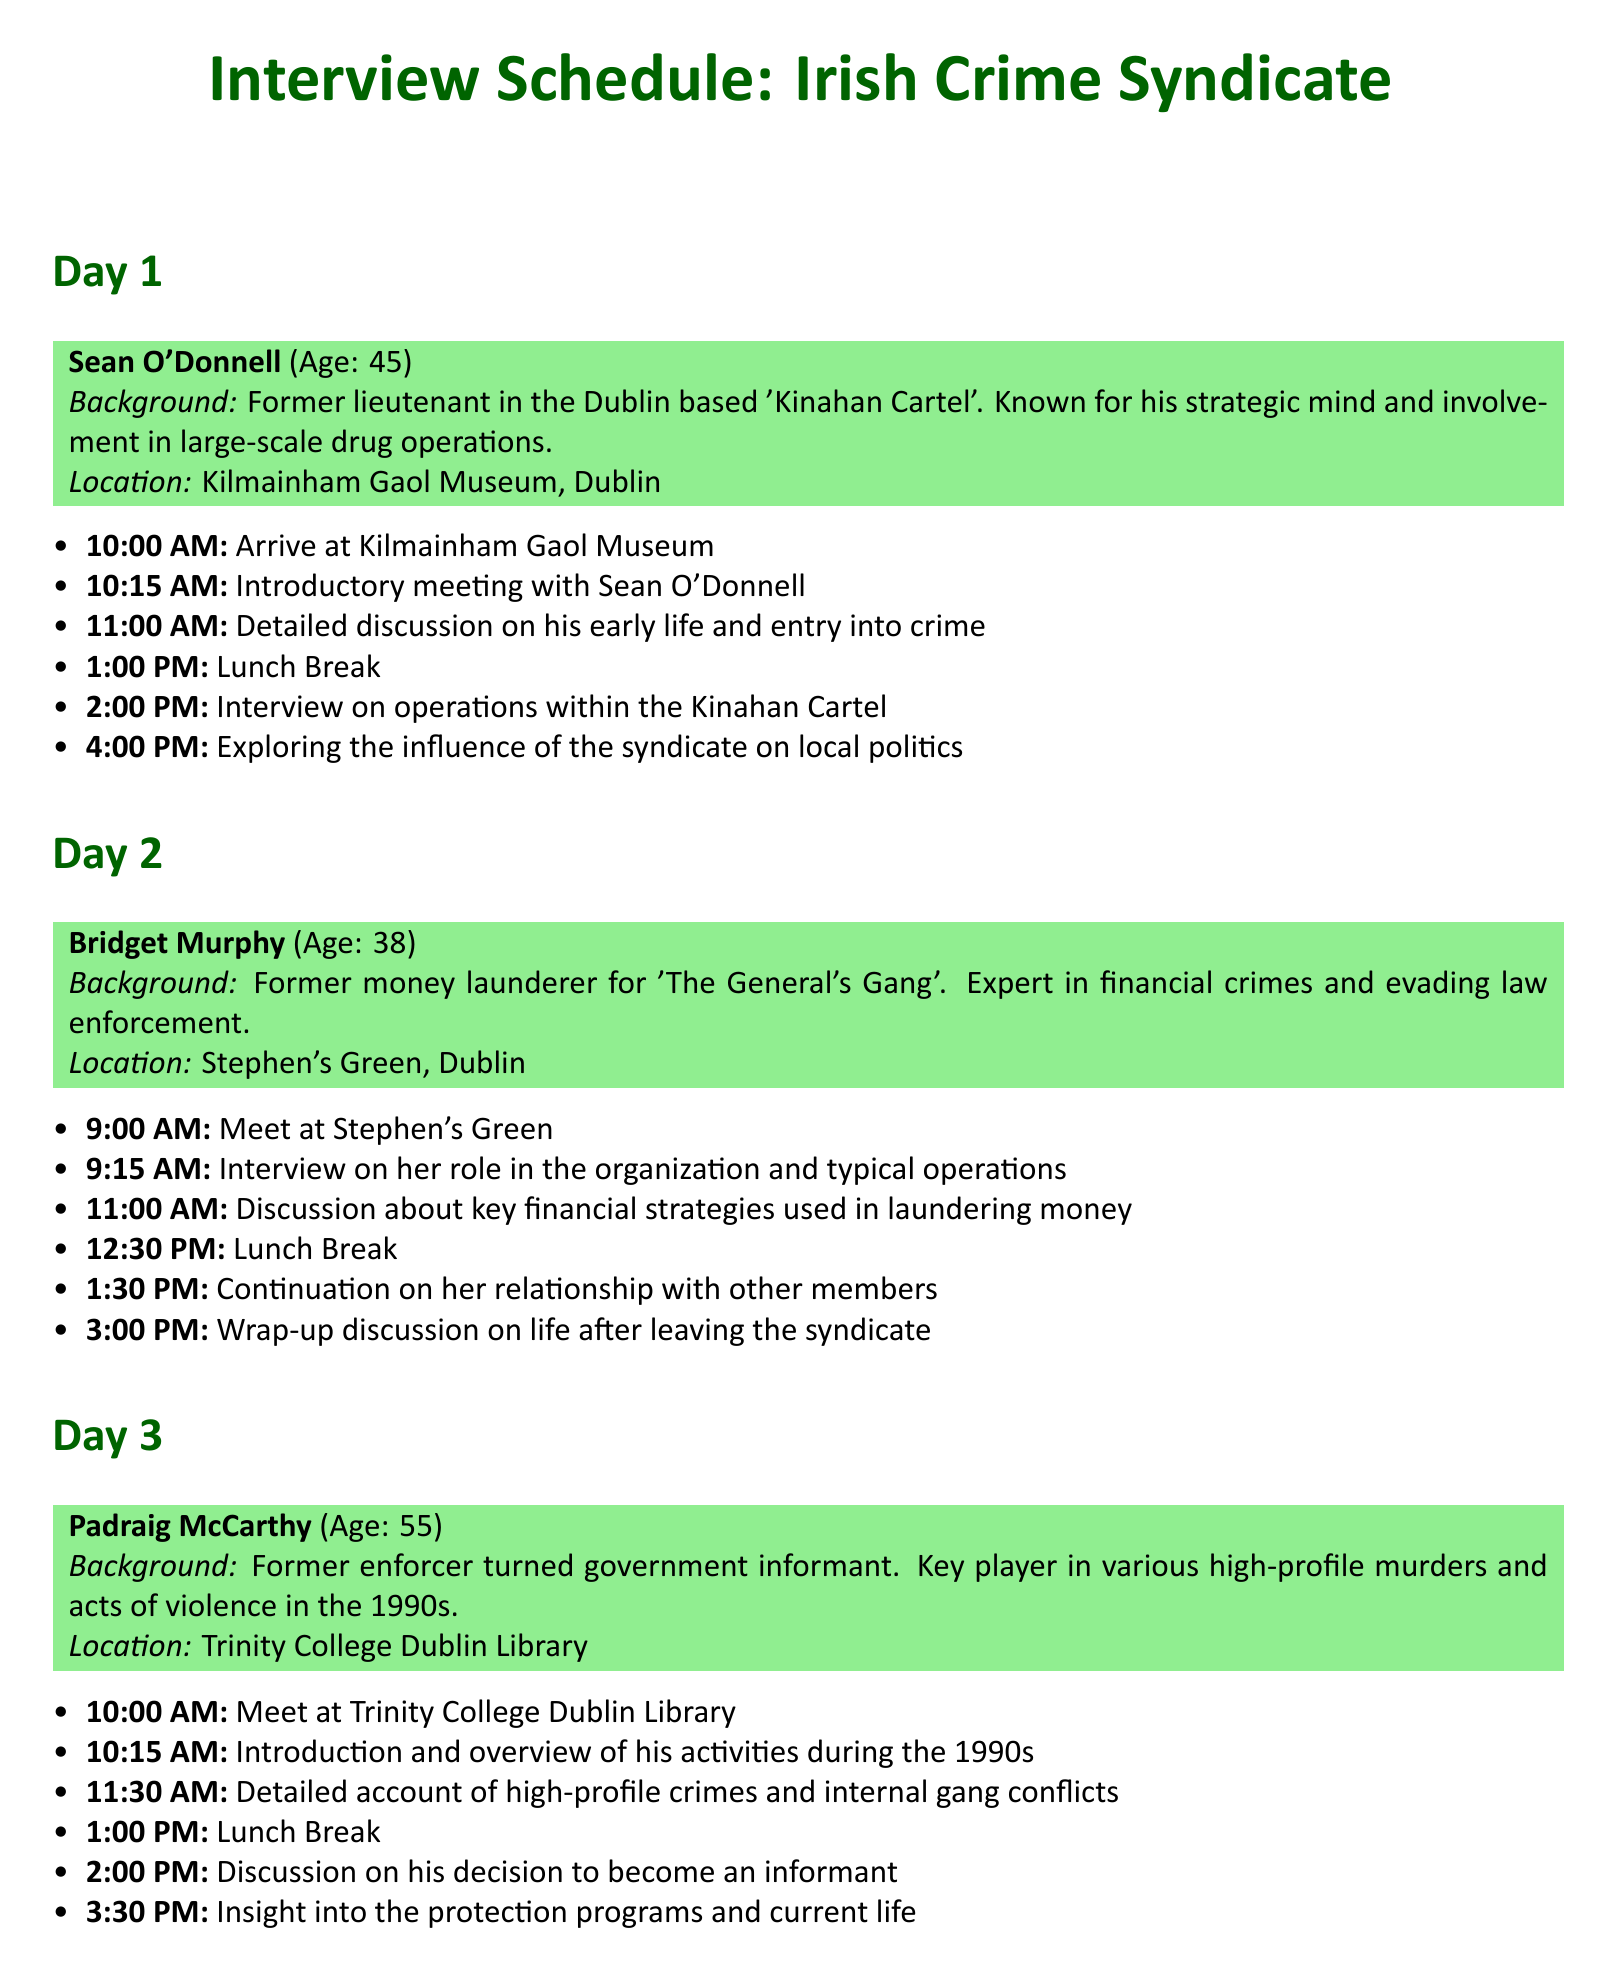What is the age of Sean O'Donnell? Sean O'Donnell's age is listed in the document as 45.
Answer: 45 Where does the interview with Bridget Murphy take place? The location for Bridget Murphy's interview is specified as Stephen's Green, Dublin.
Answer: Stephen's Green, Dublin At what time does the interview with Padraig McCarthy begin? The document states that the meeting with Padraig McCarthy starts at 10:00 AM.
Answer: 10:00 AM What was Bridget Murphy's role in the crime syndicate? The document identifies Bridget Murphy as a former money launderer for 'The General's Gang'.
Answer: Money launderer What significant life choice does Padraig McCarthy discuss during his interview? The document notes that Padraig McCarthy discusses his decision to become an informant.
Answer: Become an informant What is the focus of the discussions with Sean O'Donnell? The schedule outlines that discussions will focus on his early life, operations within the Kinahan Cartel, and local political influence.
Answer: Early life, cartel operations, local politics How long is the lunch break for Day 2? The document indicates that the lunch break on Day 2 is from 12:30 PM to 1:30 PM, which is 1 hour.
Answer: 1 hour Which former gang member is known for being strategic in drug operations? The document highlights Sean O'Donnell for his strategic mind and involvement in drug operations.
Answer: Sean O'Donnell What time does lunch break occur on Day 1? The document specifies that the lunch break on Day 1 occurs at 1:00 PM.
Answer: 1:00 PM 